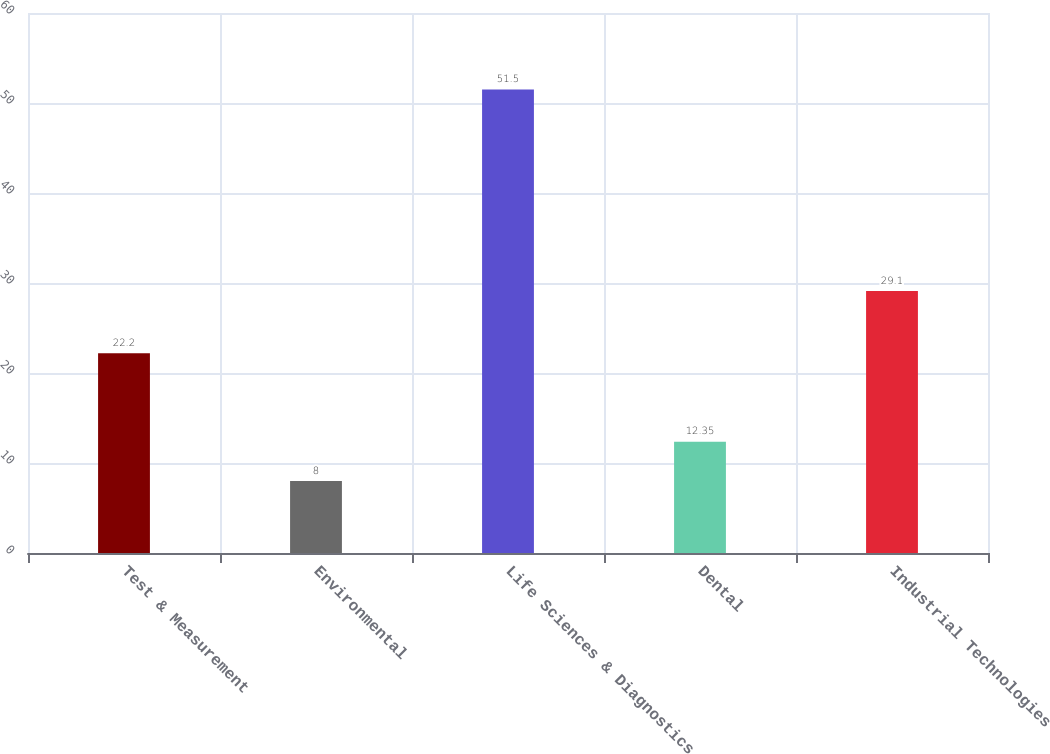<chart> <loc_0><loc_0><loc_500><loc_500><bar_chart><fcel>Test & Measurement<fcel>Environmental<fcel>Life Sciences & Diagnostics<fcel>Dental<fcel>Industrial Technologies<nl><fcel>22.2<fcel>8<fcel>51.5<fcel>12.35<fcel>29.1<nl></chart> 